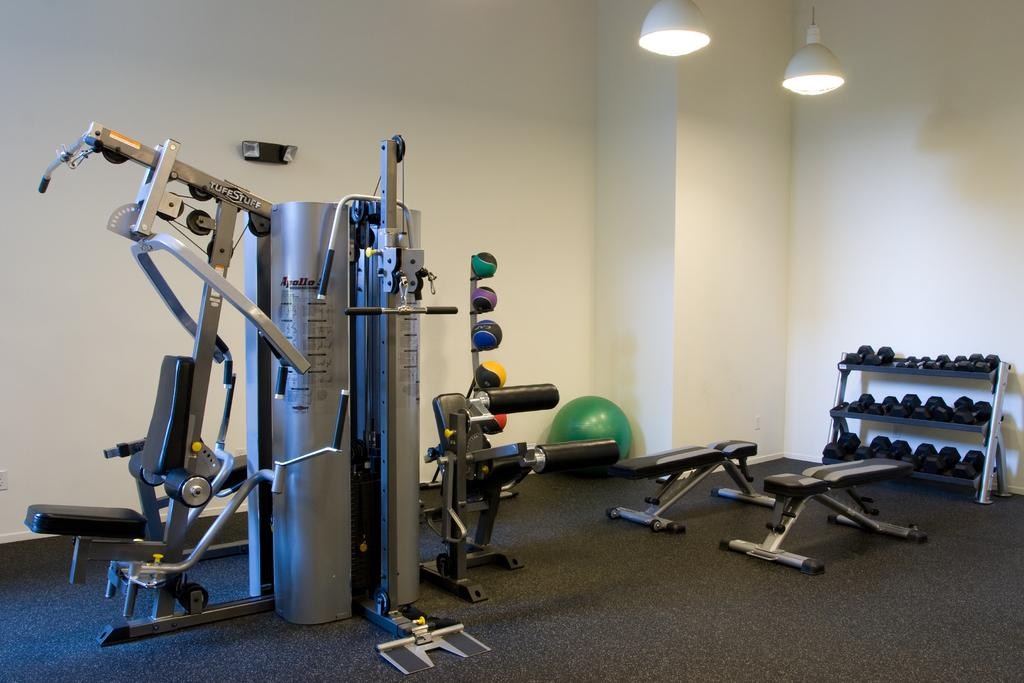What type of equipment can be found in the room? There are exercise equipment and muscle equipment in the room. Can you describe any specific exercise equipment in the room? Yes, there are dumbbells in the room. Are there any other objects related to exercise in the room? Yes, there are other objects related to exercise in the room. Can you tell me how many buns the donkey is carrying in the image? There is no donkey or buns present in the image; it features exercise equipment in a room. Is there anyone crying in the image? There is no indication of anyone crying in the image, as it focuses on exercise equipment in a room. 